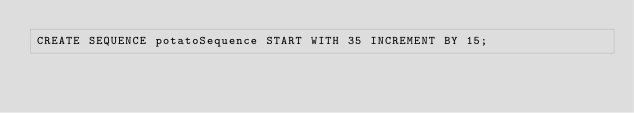Convert code to text. <code><loc_0><loc_0><loc_500><loc_500><_SQL_>CREATE SEQUENCE potatoSequence START WITH 35 INCREMENT BY 15;

</code> 